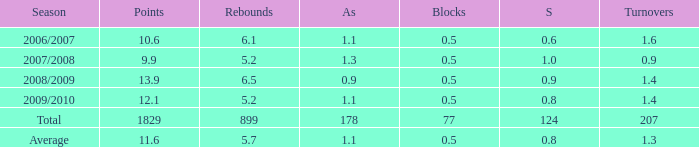What is the maximum rebounds when there are 0.9 steals and fewer than 1.4 turnovers? None. 